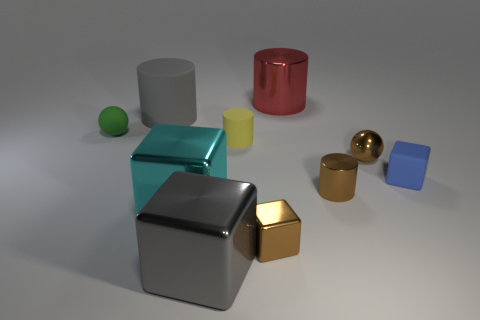Subtract all balls. How many objects are left? 8 Add 6 small green metal balls. How many small green metal balls exist? 6 Subtract 0 red spheres. How many objects are left? 10 Subtract all brown spheres. Subtract all small brown cylinders. How many objects are left? 8 Add 6 spheres. How many spheres are left? 8 